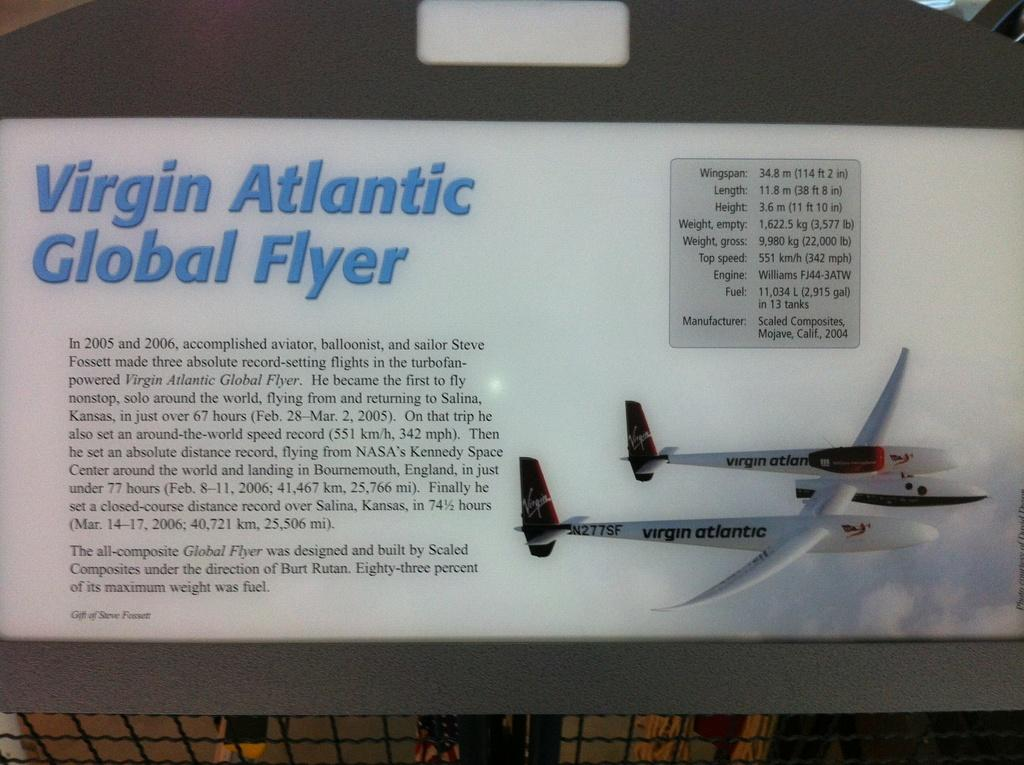What is the main subject of the image? The main subject of the image is two aircraft. What colors are the aircraft? The aircraft are in white and red colors. Are there any markings or text on the aircraft? Yes, there is text written on the aircraft. What can be seen in the background of the image? The background of the image is white. How many bridges can be seen connecting the two aircraft in the image? There are no bridges present in the image, as it features two aircraft with text on them against a white background. 